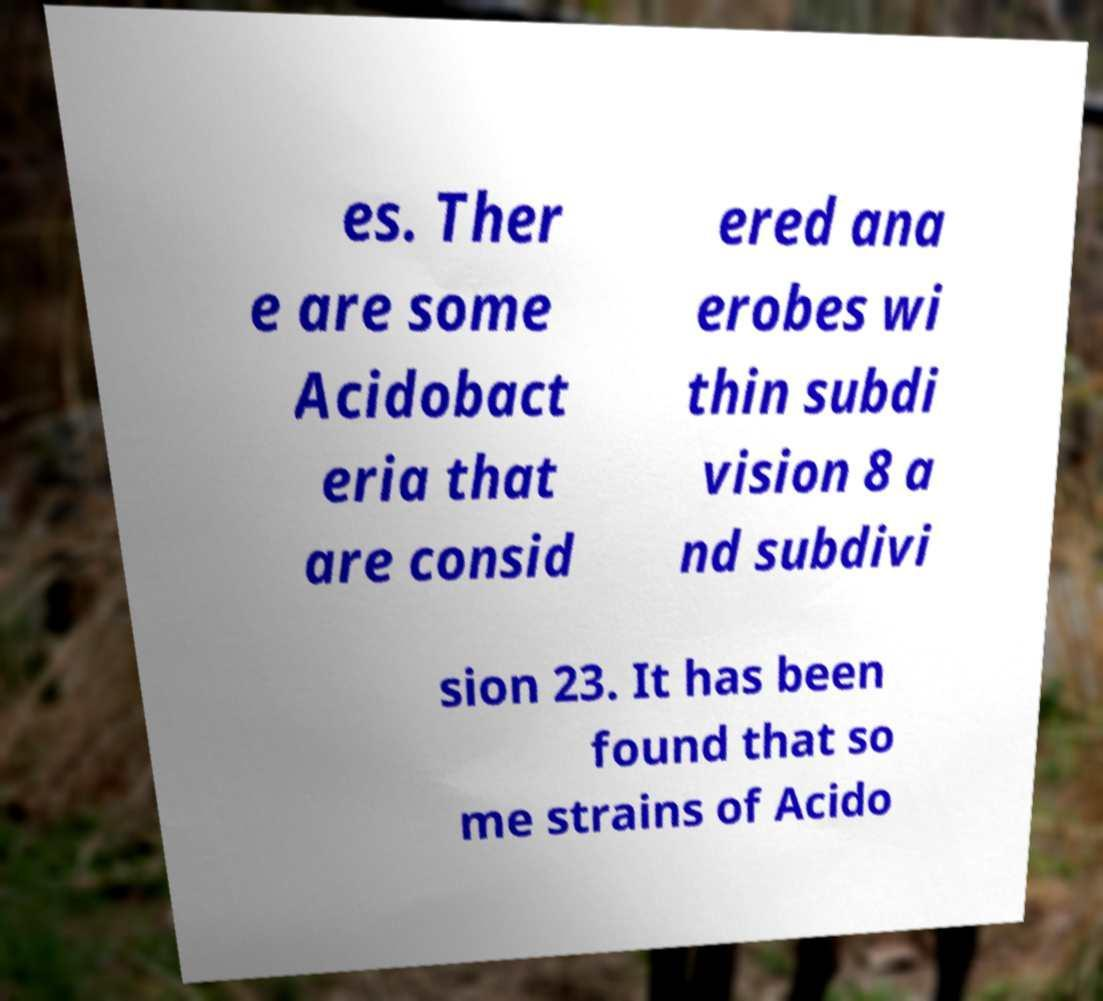I need the written content from this picture converted into text. Can you do that? es. Ther e are some Acidobact eria that are consid ered ana erobes wi thin subdi vision 8 a nd subdivi sion 23. It has been found that so me strains of Acido 